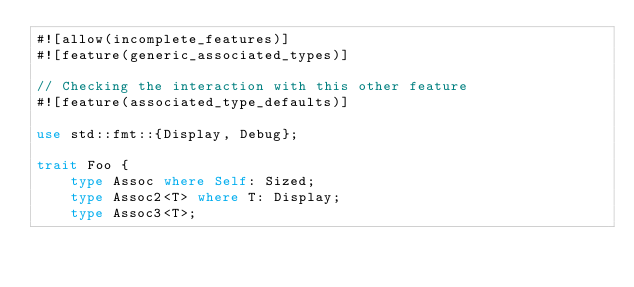<code> <loc_0><loc_0><loc_500><loc_500><_Rust_>#![allow(incomplete_features)]
#![feature(generic_associated_types)]

// Checking the interaction with this other feature
#![feature(associated_type_defaults)]

use std::fmt::{Display, Debug};

trait Foo {
    type Assoc where Self: Sized;
    type Assoc2<T> where T: Display;
    type Assoc3<T>;</code> 